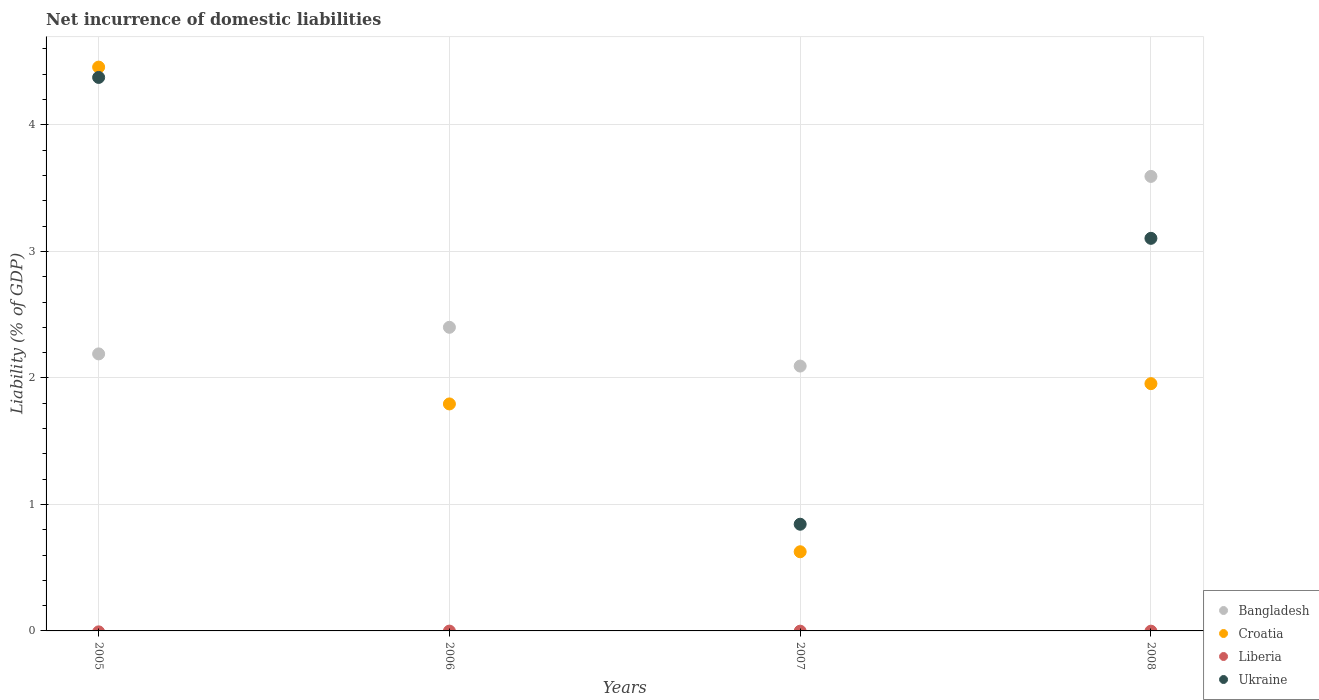How many different coloured dotlines are there?
Ensure brevity in your answer.  3. What is the net incurrence of domestic liabilities in Bangladesh in 2005?
Your answer should be compact. 2.19. Across all years, what is the maximum net incurrence of domestic liabilities in Ukraine?
Keep it short and to the point. 4.38. Across all years, what is the minimum net incurrence of domestic liabilities in Ukraine?
Provide a succinct answer. 0. What is the total net incurrence of domestic liabilities in Croatia in the graph?
Your answer should be compact. 8.83. What is the difference between the net incurrence of domestic liabilities in Bangladesh in 2006 and that in 2008?
Provide a short and direct response. -1.19. What is the difference between the net incurrence of domestic liabilities in Ukraine in 2006 and the net incurrence of domestic liabilities in Bangladesh in 2007?
Keep it short and to the point. -2.09. In the year 2007, what is the difference between the net incurrence of domestic liabilities in Bangladesh and net incurrence of domestic liabilities in Croatia?
Give a very brief answer. 1.47. In how many years, is the net incurrence of domestic liabilities in Croatia greater than 1.6 %?
Your answer should be compact. 3. What is the ratio of the net incurrence of domestic liabilities in Bangladesh in 2005 to that in 2006?
Offer a terse response. 0.91. What is the difference between the highest and the second highest net incurrence of domestic liabilities in Ukraine?
Give a very brief answer. 1.27. What is the difference between the highest and the lowest net incurrence of domestic liabilities in Bangladesh?
Your answer should be very brief. 1.5. In how many years, is the net incurrence of domestic liabilities in Bangladesh greater than the average net incurrence of domestic liabilities in Bangladesh taken over all years?
Your answer should be compact. 1. Is it the case that in every year, the sum of the net incurrence of domestic liabilities in Ukraine and net incurrence of domestic liabilities in Croatia  is greater than the sum of net incurrence of domestic liabilities in Liberia and net incurrence of domestic liabilities in Bangladesh?
Offer a very short reply. No. Does the net incurrence of domestic liabilities in Ukraine monotonically increase over the years?
Your response must be concise. No. Is the net incurrence of domestic liabilities in Bangladesh strictly less than the net incurrence of domestic liabilities in Liberia over the years?
Offer a very short reply. No. How many years are there in the graph?
Your response must be concise. 4. What is the difference between two consecutive major ticks on the Y-axis?
Make the answer very short. 1. Are the values on the major ticks of Y-axis written in scientific E-notation?
Keep it short and to the point. No. Does the graph contain any zero values?
Your answer should be compact. Yes. How many legend labels are there?
Your response must be concise. 4. What is the title of the graph?
Your answer should be very brief. Net incurrence of domestic liabilities. Does "Guinea-Bissau" appear as one of the legend labels in the graph?
Give a very brief answer. No. What is the label or title of the X-axis?
Provide a succinct answer. Years. What is the label or title of the Y-axis?
Provide a short and direct response. Liability (% of GDP). What is the Liability (% of GDP) of Bangladesh in 2005?
Keep it short and to the point. 2.19. What is the Liability (% of GDP) of Croatia in 2005?
Your answer should be compact. 4.46. What is the Liability (% of GDP) in Liberia in 2005?
Ensure brevity in your answer.  0. What is the Liability (% of GDP) in Ukraine in 2005?
Make the answer very short. 4.38. What is the Liability (% of GDP) in Bangladesh in 2006?
Your response must be concise. 2.4. What is the Liability (% of GDP) in Croatia in 2006?
Offer a terse response. 1.79. What is the Liability (% of GDP) in Liberia in 2006?
Provide a short and direct response. 0. What is the Liability (% of GDP) in Ukraine in 2006?
Provide a succinct answer. 0. What is the Liability (% of GDP) of Bangladesh in 2007?
Your answer should be compact. 2.09. What is the Liability (% of GDP) of Croatia in 2007?
Your response must be concise. 0.63. What is the Liability (% of GDP) in Ukraine in 2007?
Your answer should be very brief. 0.84. What is the Liability (% of GDP) in Bangladesh in 2008?
Provide a succinct answer. 3.59. What is the Liability (% of GDP) in Croatia in 2008?
Offer a very short reply. 1.95. What is the Liability (% of GDP) of Ukraine in 2008?
Provide a short and direct response. 3.1. Across all years, what is the maximum Liability (% of GDP) of Bangladesh?
Offer a terse response. 3.59. Across all years, what is the maximum Liability (% of GDP) of Croatia?
Ensure brevity in your answer.  4.46. Across all years, what is the maximum Liability (% of GDP) in Ukraine?
Keep it short and to the point. 4.38. Across all years, what is the minimum Liability (% of GDP) of Bangladesh?
Your answer should be very brief. 2.09. Across all years, what is the minimum Liability (% of GDP) in Croatia?
Make the answer very short. 0.63. What is the total Liability (% of GDP) in Bangladesh in the graph?
Provide a succinct answer. 10.28. What is the total Liability (% of GDP) of Croatia in the graph?
Give a very brief answer. 8.83. What is the total Liability (% of GDP) in Liberia in the graph?
Offer a very short reply. 0. What is the total Liability (% of GDP) of Ukraine in the graph?
Provide a succinct answer. 8.32. What is the difference between the Liability (% of GDP) in Bangladesh in 2005 and that in 2006?
Offer a very short reply. -0.21. What is the difference between the Liability (% of GDP) in Croatia in 2005 and that in 2006?
Your answer should be very brief. 2.66. What is the difference between the Liability (% of GDP) of Bangladesh in 2005 and that in 2007?
Your response must be concise. 0.1. What is the difference between the Liability (% of GDP) in Croatia in 2005 and that in 2007?
Keep it short and to the point. 3.83. What is the difference between the Liability (% of GDP) of Ukraine in 2005 and that in 2007?
Your answer should be compact. 3.53. What is the difference between the Liability (% of GDP) of Bangladesh in 2005 and that in 2008?
Offer a terse response. -1.4. What is the difference between the Liability (% of GDP) of Croatia in 2005 and that in 2008?
Provide a succinct answer. 2.5. What is the difference between the Liability (% of GDP) of Ukraine in 2005 and that in 2008?
Provide a succinct answer. 1.27. What is the difference between the Liability (% of GDP) of Bangladesh in 2006 and that in 2007?
Ensure brevity in your answer.  0.31. What is the difference between the Liability (% of GDP) in Croatia in 2006 and that in 2007?
Give a very brief answer. 1.17. What is the difference between the Liability (% of GDP) of Bangladesh in 2006 and that in 2008?
Make the answer very short. -1.19. What is the difference between the Liability (% of GDP) in Croatia in 2006 and that in 2008?
Keep it short and to the point. -0.16. What is the difference between the Liability (% of GDP) of Bangladesh in 2007 and that in 2008?
Offer a terse response. -1.5. What is the difference between the Liability (% of GDP) of Croatia in 2007 and that in 2008?
Your answer should be compact. -1.33. What is the difference between the Liability (% of GDP) of Ukraine in 2007 and that in 2008?
Offer a terse response. -2.26. What is the difference between the Liability (% of GDP) in Bangladesh in 2005 and the Liability (% of GDP) in Croatia in 2006?
Your answer should be very brief. 0.4. What is the difference between the Liability (% of GDP) of Bangladesh in 2005 and the Liability (% of GDP) of Croatia in 2007?
Your answer should be very brief. 1.56. What is the difference between the Liability (% of GDP) of Bangladesh in 2005 and the Liability (% of GDP) of Ukraine in 2007?
Ensure brevity in your answer.  1.35. What is the difference between the Liability (% of GDP) of Croatia in 2005 and the Liability (% of GDP) of Ukraine in 2007?
Keep it short and to the point. 3.61. What is the difference between the Liability (% of GDP) of Bangladesh in 2005 and the Liability (% of GDP) of Croatia in 2008?
Offer a very short reply. 0.24. What is the difference between the Liability (% of GDP) of Bangladesh in 2005 and the Liability (% of GDP) of Ukraine in 2008?
Ensure brevity in your answer.  -0.91. What is the difference between the Liability (% of GDP) of Croatia in 2005 and the Liability (% of GDP) of Ukraine in 2008?
Offer a very short reply. 1.35. What is the difference between the Liability (% of GDP) in Bangladesh in 2006 and the Liability (% of GDP) in Croatia in 2007?
Offer a terse response. 1.77. What is the difference between the Liability (% of GDP) in Bangladesh in 2006 and the Liability (% of GDP) in Ukraine in 2007?
Offer a very short reply. 1.56. What is the difference between the Liability (% of GDP) in Croatia in 2006 and the Liability (% of GDP) in Ukraine in 2007?
Make the answer very short. 0.95. What is the difference between the Liability (% of GDP) of Bangladesh in 2006 and the Liability (% of GDP) of Croatia in 2008?
Make the answer very short. 0.45. What is the difference between the Liability (% of GDP) of Bangladesh in 2006 and the Liability (% of GDP) of Ukraine in 2008?
Provide a succinct answer. -0.7. What is the difference between the Liability (% of GDP) of Croatia in 2006 and the Liability (% of GDP) of Ukraine in 2008?
Your answer should be compact. -1.31. What is the difference between the Liability (% of GDP) in Bangladesh in 2007 and the Liability (% of GDP) in Croatia in 2008?
Your answer should be very brief. 0.14. What is the difference between the Liability (% of GDP) in Bangladesh in 2007 and the Liability (% of GDP) in Ukraine in 2008?
Your response must be concise. -1.01. What is the difference between the Liability (% of GDP) in Croatia in 2007 and the Liability (% of GDP) in Ukraine in 2008?
Make the answer very short. -2.48. What is the average Liability (% of GDP) of Bangladesh per year?
Give a very brief answer. 2.57. What is the average Liability (% of GDP) of Croatia per year?
Offer a terse response. 2.21. What is the average Liability (% of GDP) of Liberia per year?
Offer a terse response. 0. What is the average Liability (% of GDP) of Ukraine per year?
Give a very brief answer. 2.08. In the year 2005, what is the difference between the Liability (% of GDP) of Bangladesh and Liability (% of GDP) of Croatia?
Ensure brevity in your answer.  -2.27. In the year 2005, what is the difference between the Liability (% of GDP) in Bangladesh and Liability (% of GDP) in Ukraine?
Offer a very short reply. -2.19. In the year 2005, what is the difference between the Liability (% of GDP) of Croatia and Liability (% of GDP) of Ukraine?
Offer a terse response. 0.08. In the year 2006, what is the difference between the Liability (% of GDP) of Bangladesh and Liability (% of GDP) of Croatia?
Offer a terse response. 0.61. In the year 2007, what is the difference between the Liability (% of GDP) in Bangladesh and Liability (% of GDP) in Croatia?
Offer a very short reply. 1.47. In the year 2007, what is the difference between the Liability (% of GDP) of Bangladesh and Liability (% of GDP) of Ukraine?
Offer a terse response. 1.25. In the year 2007, what is the difference between the Liability (% of GDP) in Croatia and Liability (% of GDP) in Ukraine?
Provide a short and direct response. -0.22. In the year 2008, what is the difference between the Liability (% of GDP) in Bangladesh and Liability (% of GDP) in Croatia?
Offer a very short reply. 1.64. In the year 2008, what is the difference between the Liability (% of GDP) in Bangladesh and Liability (% of GDP) in Ukraine?
Offer a terse response. 0.49. In the year 2008, what is the difference between the Liability (% of GDP) in Croatia and Liability (% of GDP) in Ukraine?
Offer a terse response. -1.15. What is the ratio of the Liability (% of GDP) of Bangladesh in 2005 to that in 2006?
Ensure brevity in your answer.  0.91. What is the ratio of the Liability (% of GDP) in Croatia in 2005 to that in 2006?
Your answer should be compact. 2.48. What is the ratio of the Liability (% of GDP) in Bangladesh in 2005 to that in 2007?
Your answer should be compact. 1.05. What is the ratio of the Liability (% of GDP) of Croatia in 2005 to that in 2007?
Offer a very short reply. 7.12. What is the ratio of the Liability (% of GDP) of Ukraine in 2005 to that in 2007?
Keep it short and to the point. 5.19. What is the ratio of the Liability (% of GDP) of Bangladesh in 2005 to that in 2008?
Provide a succinct answer. 0.61. What is the ratio of the Liability (% of GDP) in Croatia in 2005 to that in 2008?
Give a very brief answer. 2.28. What is the ratio of the Liability (% of GDP) of Ukraine in 2005 to that in 2008?
Provide a succinct answer. 1.41. What is the ratio of the Liability (% of GDP) in Bangladesh in 2006 to that in 2007?
Your response must be concise. 1.15. What is the ratio of the Liability (% of GDP) in Croatia in 2006 to that in 2007?
Offer a very short reply. 2.87. What is the ratio of the Liability (% of GDP) in Bangladesh in 2006 to that in 2008?
Keep it short and to the point. 0.67. What is the ratio of the Liability (% of GDP) in Croatia in 2006 to that in 2008?
Ensure brevity in your answer.  0.92. What is the ratio of the Liability (% of GDP) of Bangladesh in 2007 to that in 2008?
Your answer should be compact. 0.58. What is the ratio of the Liability (% of GDP) of Croatia in 2007 to that in 2008?
Give a very brief answer. 0.32. What is the ratio of the Liability (% of GDP) of Ukraine in 2007 to that in 2008?
Provide a succinct answer. 0.27. What is the difference between the highest and the second highest Liability (% of GDP) of Bangladesh?
Your answer should be compact. 1.19. What is the difference between the highest and the second highest Liability (% of GDP) in Croatia?
Offer a terse response. 2.5. What is the difference between the highest and the second highest Liability (% of GDP) of Ukraine?
Give a very brief answer. 1.27. What is the difference between the highest and the lowest Liability (% of GDP) in Bangladesh?
Offer a terse response. 1.5. What is the difference between the highest and the lowest Liability (% of GDP) of Croatia?
Your answer should be compact. 3.83. What is the difference between the highest and the lowest Liability (% of GDP) of Ukraine?
Provide a short and direct response. 4.38. 